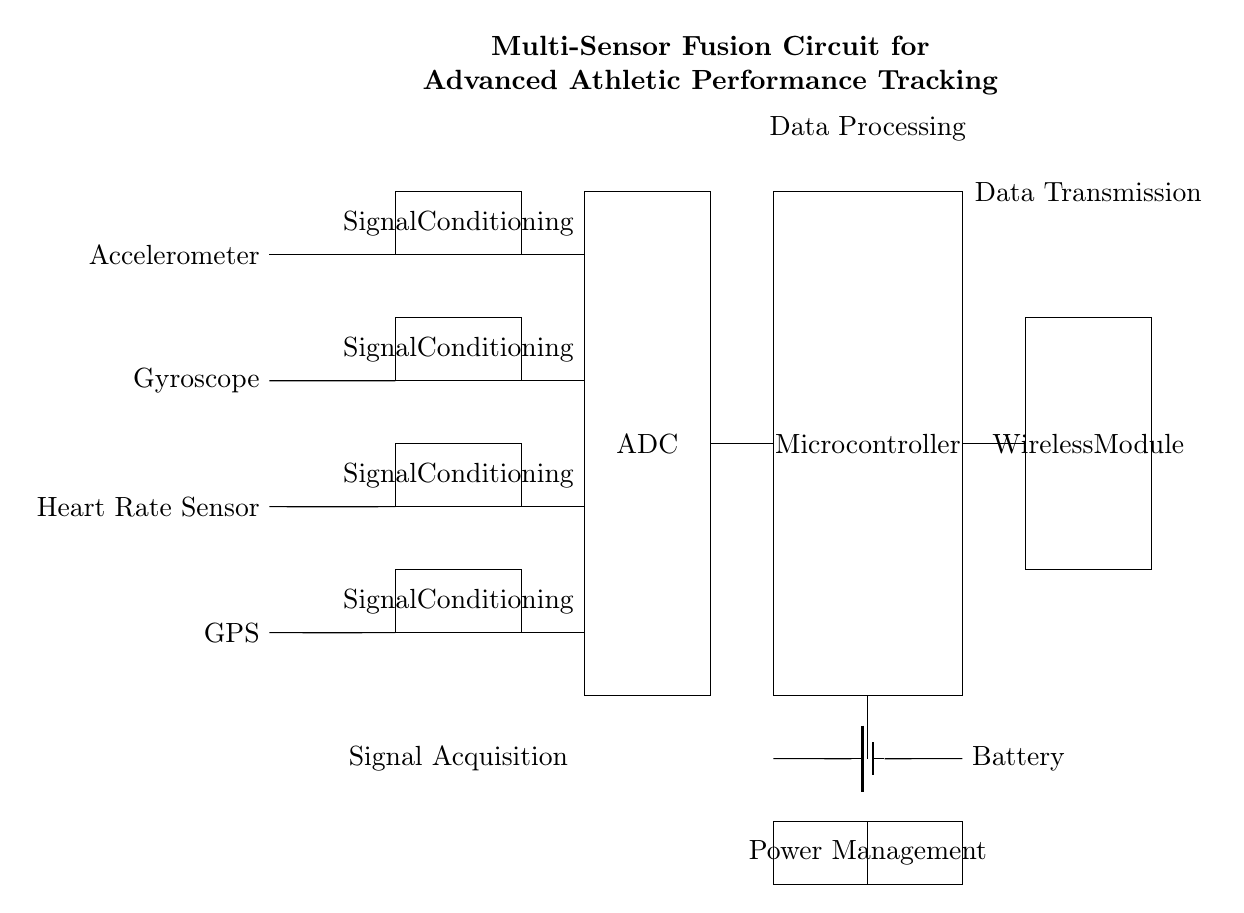What type of sensors are used in this circuit? The circuit includes an accelerometer, gyroscope, heart rate sensor, and GPS, which are listed on the left side of the diagram.
Answer: accelerometer, gyroscope, heart rate sensor, GPS What component processes the signals from the sensors? Each sensor is connected to its respective signal conditioning block, indicated by rectangles to the right of each sensor line.
Answer: Signal Conditioning How many signal conditioning units are present? There are four sensors, each with a corresponding signal conditioning unit, resulting in four total units in the circuit.
Answer: 4 What is the function of the ADC in the circuit? The ADC receives conditioned signals from each sensor to convert them into digital format for processing by the microcontroller.
Answer: Analog to Digital Conversion Which component transmits data wirelessly? The Wireless Module, represented as a rectangle towards the end of the circuit, is responsible for data transmission.
Answer: Wireless Module What is the primary role of the microcontroller in this circuit? The microcontroller receives digital signals from the ADC, processes the data, and is crucial for the functioning of the circuit's logic.
Answer: Data Processing What type of power source is used for this circuit? The circuit utilizes a battery as its power source, indicated by the battery symbol in the power management section of the diagram.
Answer: Battery 